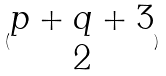<formula> <loc_0><loc_0><loc_500><loc_500>( \begin{matrix} p + q + 3 \\ 2 \end{matrix} )</formula> 